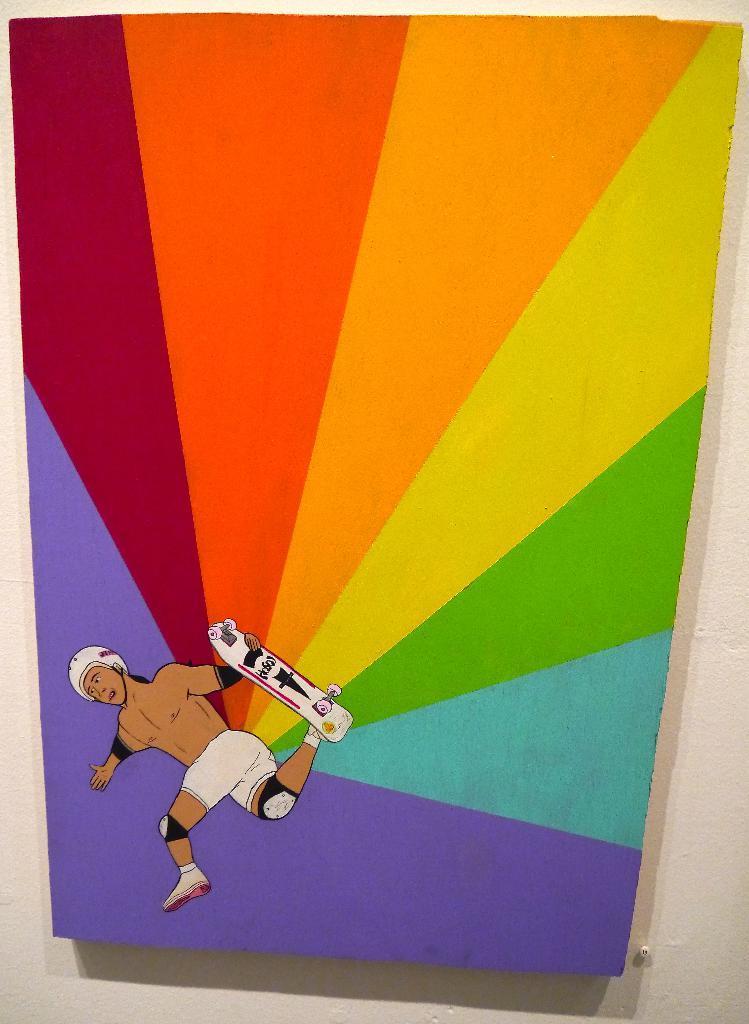Can you describe this image briefly? In this image we can see painting of a person holding a skateboard in his hand and a design on the board on the wall. 